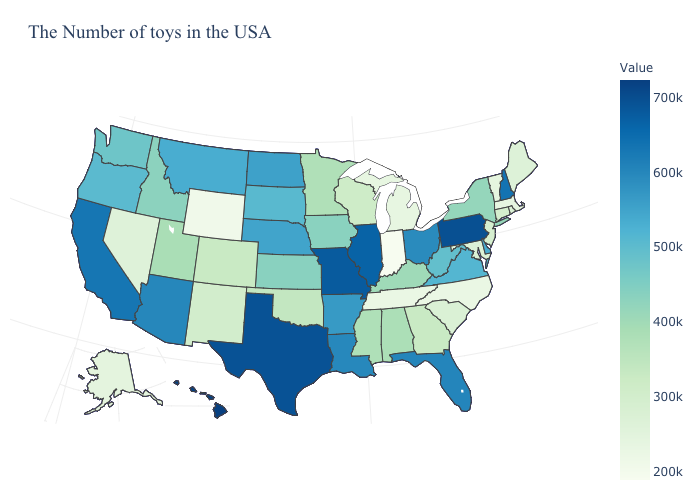Does Tennessee have the lowest value in the South?
Write a very short answer. Yes. Does Iowa have the lowest value in the MidWest?
Give a very brief answer. No. Which states hav the highest value in the West?
Give a very brief answer. Hawaii. Which states have the lowest value in the USA?
Answer briefly. Indiana. Which states have the lowest value in the USA?
Keep it brief. Indiana. 